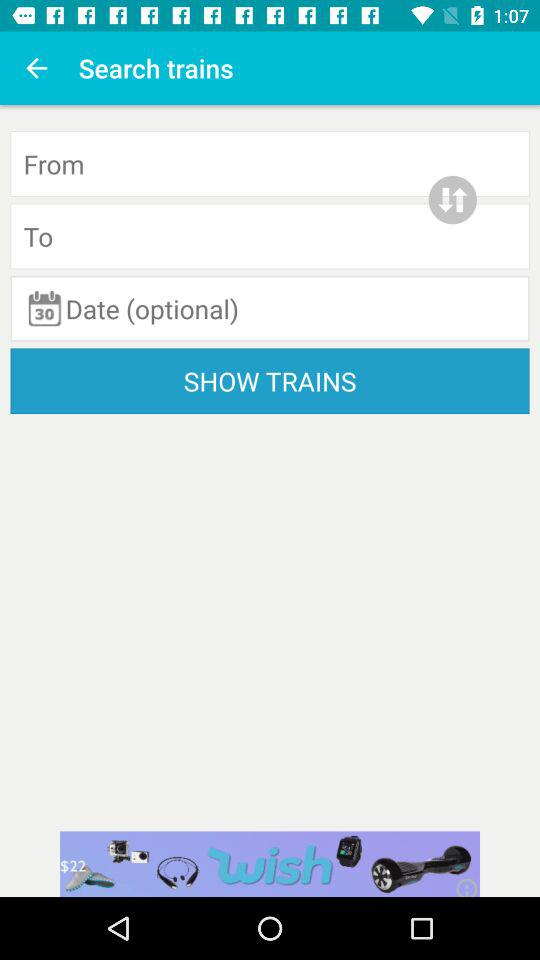What is the optional date?
When the provided information is insufficient, respond with <no answer>. <no answer> 